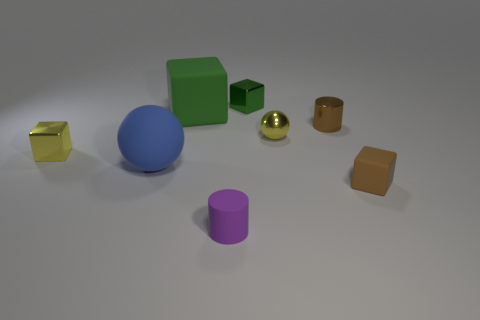Subtract all yellow metallic cubes. How many cubes are left? 3 Subtract 1 cubes. How many cubes are left? 3 Subtract all brown blocks. How many blocks are left? 3 Subtract all gray cubes. Subtract all blue cylinders. How many cubes are left? 4 Add 2 tiny things. How many objects exist? 10 Subtract all cylinders. How many objects are left? 6 Subtract 1 brown cubes. How many objects are left? 7 Subtract all tiny brown cubes. Subtract all purple matte cylinders. How many objects are left? 6 Add 5 blue matte spheres. How many blue matte spheres are left? 6 Add 8 small blue balls. How many small blue balls exist? 8 